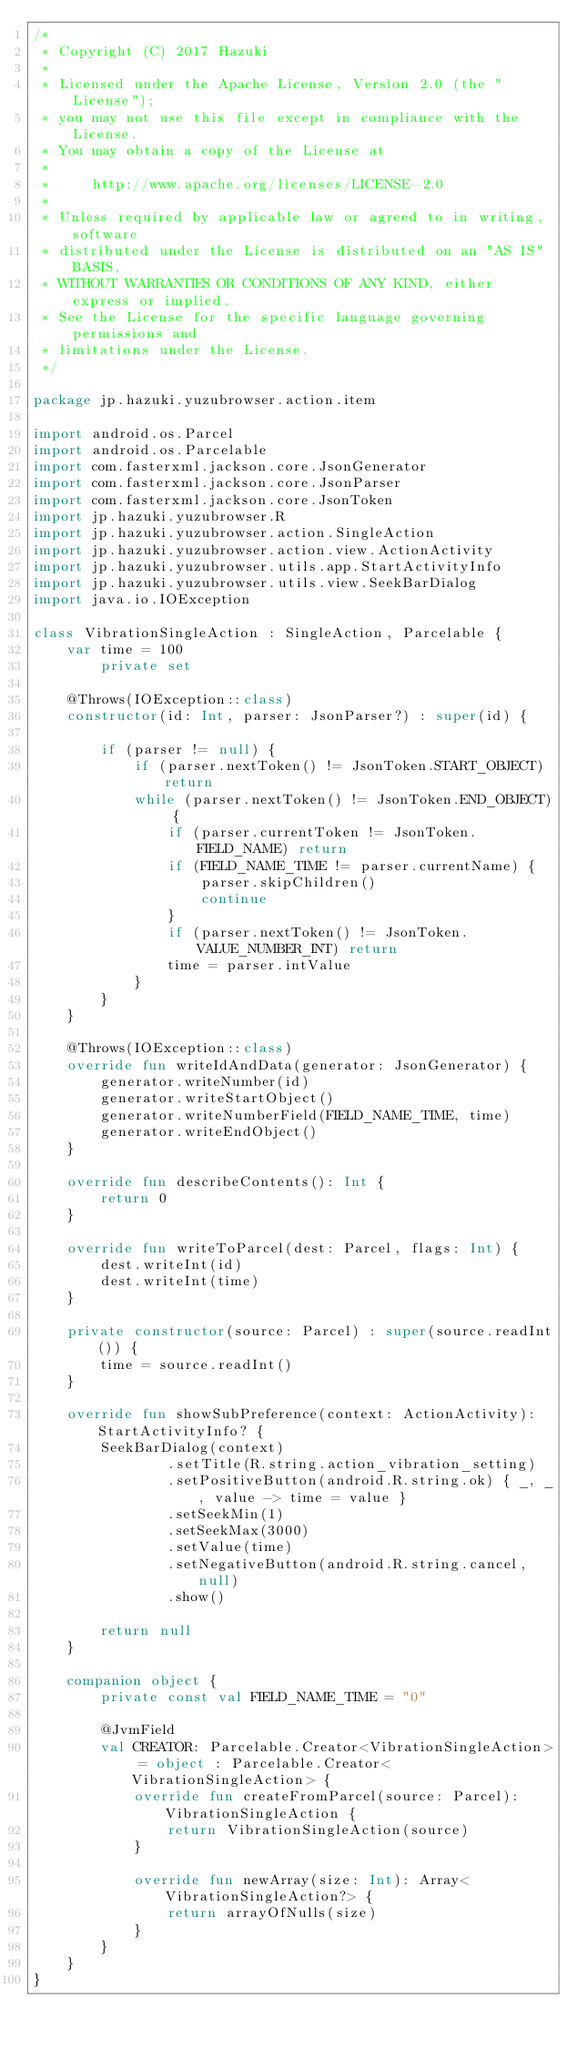Convert code to text. <code><loc_0><loc_0><loc_500><loc_500><_Kotlin_>/*
 * Copyright (C) 2017 Hazuki
 *
 * Licensed under the Apache License, Version 2.0 (the "License");
 * you may not use this file except in compliance with the License.
 * You may obtain a copy of the License at
 *
 *     http://www.apache.org/licenses/LICENSE-2.0
 *
 * Unless required by applicable law or agreed to in writing, software
 * distributed under the License is distributed on an "AS IS" BASIS,
 * WITHOUT WARRANTIES OR CONDITIONS OF ANY KIND, either express or implied.
 * See the License for the specific language governing permissions and
 * limitations under the License.
 */

package jp.hazuki.yuzubrowser.action.item

import android.os.Parcel
import android.os.Parcelable
import com.fasterxml.jackson.core.JsonGenerator
import com.fasterxml.jackson.core.JsonParser
import com.fasterxml.jackson.core.JsonToken
import jp.hazuki.yuzubrowser.R
import jp.hazuki.yuzubrowser.action.SingleAction
import jp.hazuki.yuzubrowser.action.view.ActionActivity
import jp.hazuki.yuzubrowser.utils.app.StartActivityInfo
import jp.hazuki.yuzubrowser.utils.view.SeekBarDialog
import java.io.IOException

class VibrationSingleAction : SingleAction, Parcelable {
    var time = 100
        private set

    @Throws(IOException::class)
    constructor(id: Int, parser: JsonParser?) : super(id) {

        if (parser != null) {
            if (parser.nextToken() != JsonToken.START_OBJECT) return
            while (parser.nextToken() != JsonToken.END_OBJECT) {
                if (parser.currentToken != JsonToken.FIELD_NAME) return
                if (FIELD_NAME_TIME != parser.currentName) {
                    parser.skipChildren()
                    continue
                }
                if (parser.nextToken() != JsonToken.VALUE_NUMBER_INT) return
                time = parser.intValue
            }
        }
    }

    @Throws(IOException::class)
    override fun writeIdAndData(generator: JsonGenerator) {
        generator.writeNumber(id)
        generator.writeStartObject()
        generator.writeNumberField(FIELD_NAME_TIME, time)
        generator.writeEndObject()
    }

    override fun describeContents(): Int {
        return 0
    }

    override fun writeToParcel(dest: Parcel, flags: Int) {
        dest.writeInt(id)
        dest.writeInt(time)
    }

    private constructor(source: Parcel) : super(source.readInt()) {
        time = source.readInt()
    }

    override fun showSubPreference(context: ActionActivity): StartActivityInfo? {
        SeekBarDialog(context)
                .setTitle(R.string.action_vibration_setting)
                .setPositiveButton(android.R.string.ok) { _, _, value -> time = value }
                .setSeekMin(1)
                .setSeekMax(3000)
                .setValue(time)
                .setNegativeButton(android.R.string.cancel, null)
                .show()

        return null
    }

    companion object {
        private const val FIELD_NAME_TIME = "0"

        @JvmField
        val CREATOR: Parcelable.Creator<VibrationSingleAction> = object : Parcelable.Creator<VibrationSingleAction> {
            override fun createFromParcel(source: Parcel): VibrationSingleAction {
                return VibrationSingleAction(source)
            }

            override fun newArray(size: Int): Array<VibrationSingleAction?> {
                return arrayOfNulls(size)
            }
        }
    }
}
</code> 